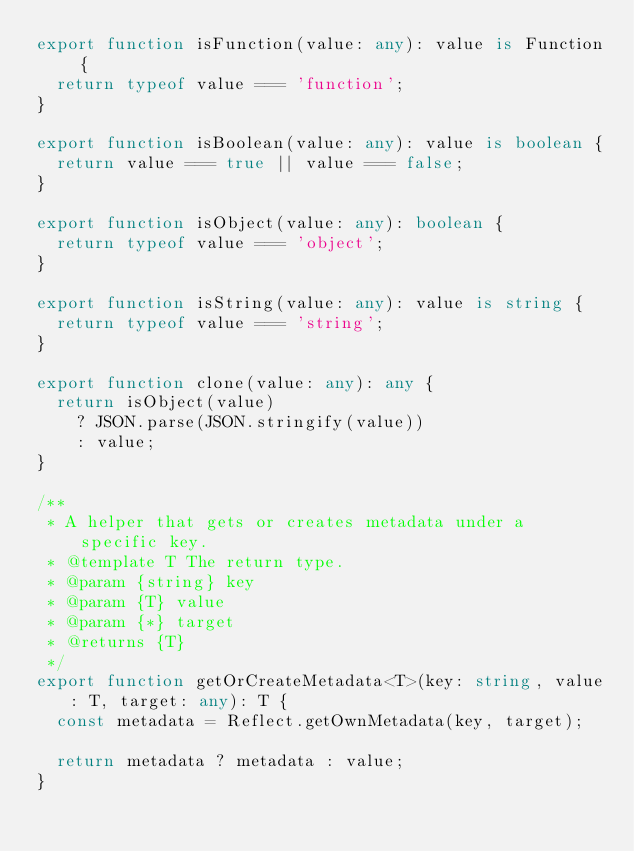<code> <loc_0><loc_0><loc_500><loc_500><_TypeScript_>export function isFunction(value: any): value is Function {
  return typeof value === 'function';
}

export function isBoolean(value: any): value is boolean {
  return value === true || value === false;
}

export function isObject(value: any): boolean {
  return typeof value === 'object';
}

export function isString(value: any): value is string {
  return typeof value === 'string';
}

export function clone(value: any): any {
  return isObject(value)
    ? JSON.parse(JSON.stringify(value))
    : value;
}

/**
 * A helper that gets or creates metadata under a specific key.
 * @template T The return type.
 * @param {string} key
 * @param {T} value
 * @param {*} target
 * @returns {T}
 */
export function getOrCreateMetadata<T>(key: string, value: T, target: any): T {
  const metadata = Reflect.getOwnMetadata(key, target);

  return metadata ? metadata : value;
}</code> 